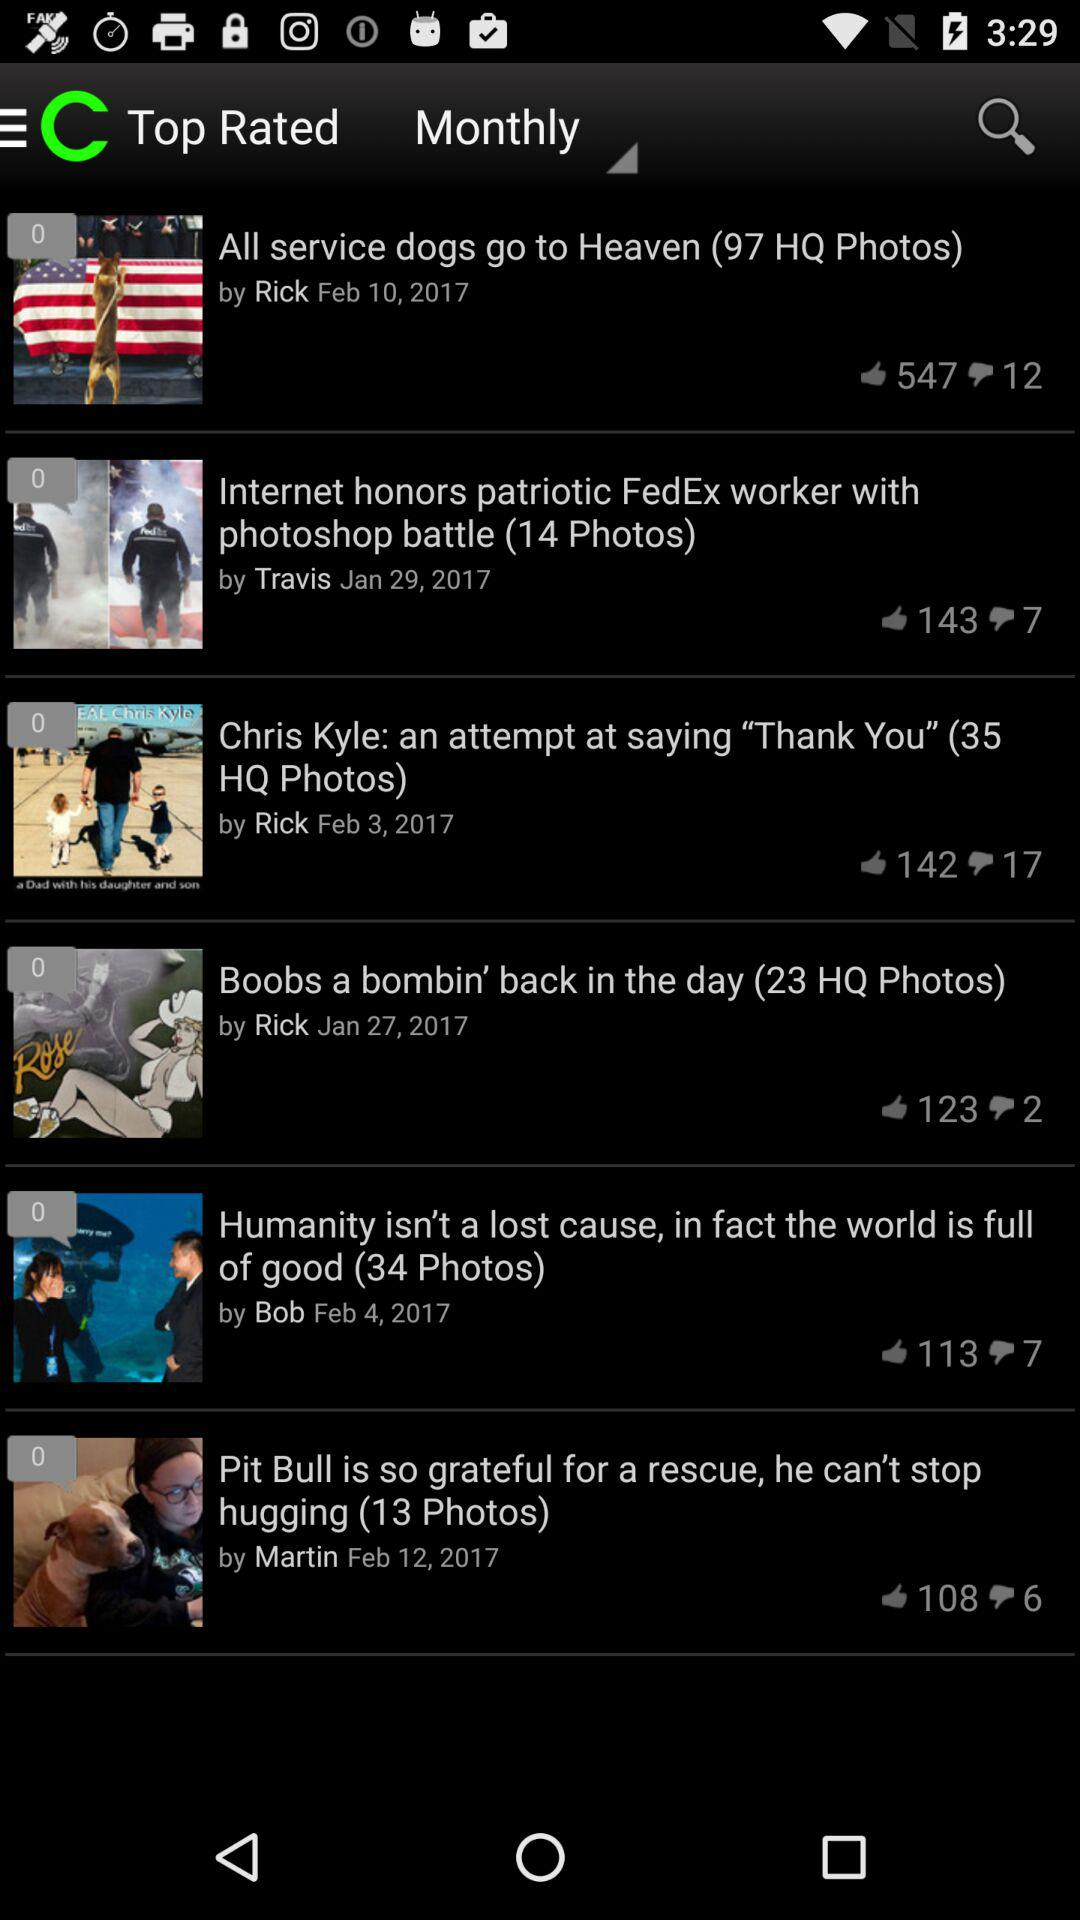Which news has 143 likes? The news "Internet honors patriotic FedEx worker with photoshop battle (14 photos)" has 143 likes. 